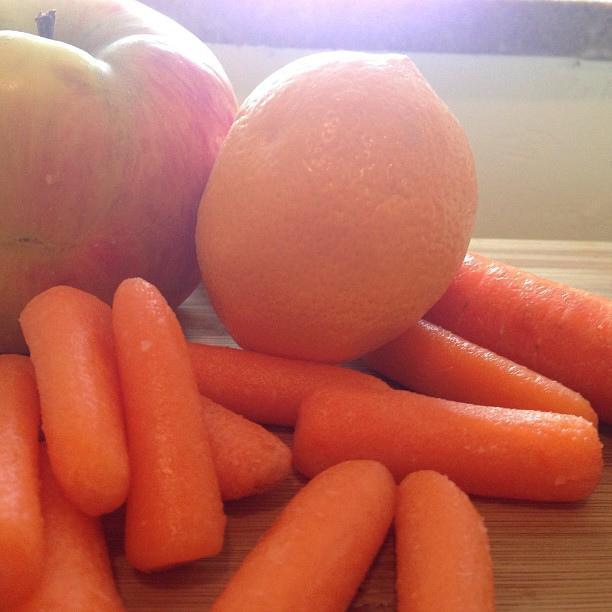How many carrots are in the picture?
Give a very brief answer. 10. 